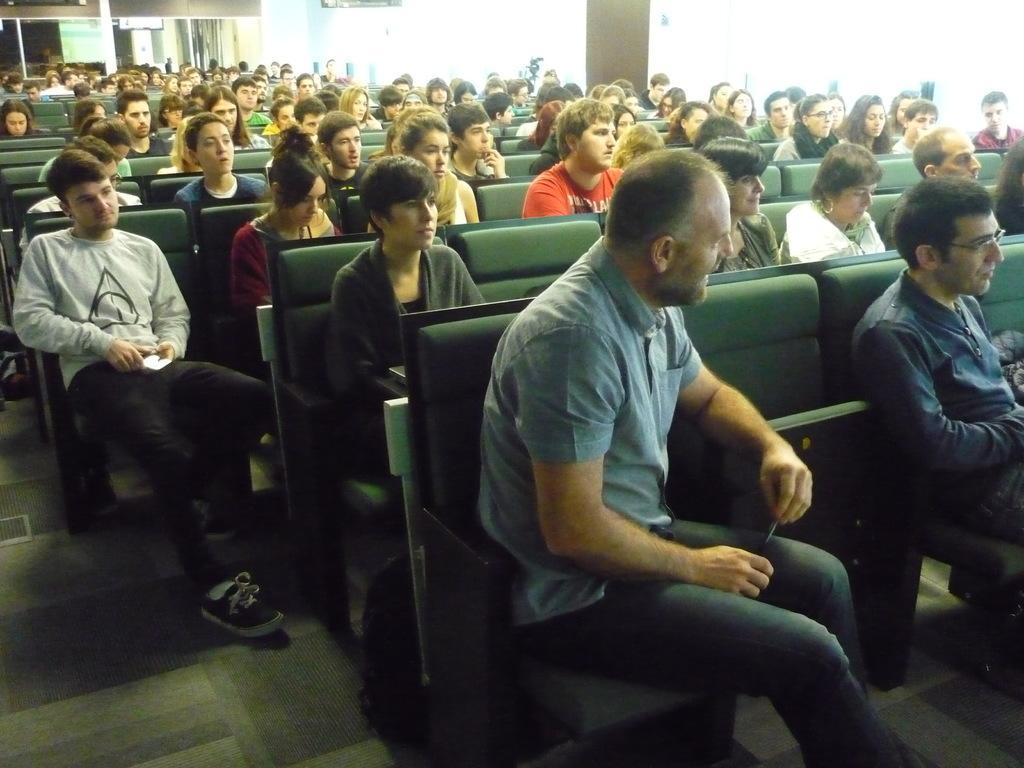Could you give a brief overview of what you see in this image? In this image I can see the group of people sitting on the chairs. These people are wearing the different color dresses and I can see the chairs are in green color. In the background I can see the glass and the pillar. 